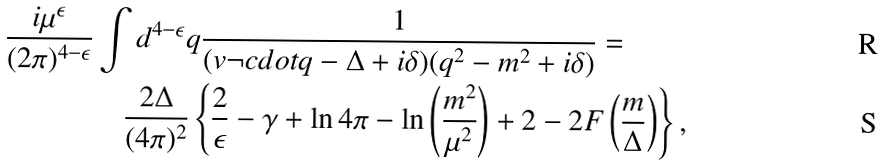<formula> <loc_0><loc_0><loc_500><loc_500>\frac { i \mu ^ { \epsilon } } { ( 2 \pi ) ^ { 4 - \epsilon } } & \int d ^ { 4 - \epsilon } q \frac { 1 } { ( v \neg c d o t q - \Delta + i \delta ) ( q ^ { 2 } - m ^ { 2 } + i \delta ) } = \\ & \quad \frac { 2 \Delta } { ( 4 \pi ) ^ { 2 } } \left \{ \frac { 2 } { \epsilon } - \gamma + \ln 4 \pi - \ln \left ( \frac { m ^ { 2 } } { \mu ^ { 2 } } \right ) + 2 - 2 F \left ( \frac { m } { \Delta } \right ) \right \} ,</formula> 